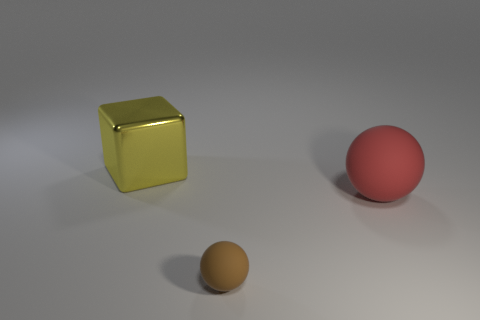Subtract all blue blocks. Subtract all cyan cylinders. How many blocks are left? 1 Add 1 brown matte objects. How many objects exist? 4 Subtract all balls. How many objects are left? 1 Add 2 blue cubes. How many blue cubes exist? 2 Subtract 0 purple blocks. How many objects are left? 3 Subtract all yellow shiny things. Subtract all blue things. How many objects are left? 2 Add 1 big rubber objects. How many big rubber objects are left? 2 